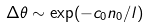<formula> <loc_0><loc_0><loc_500><loc_500>\Delta \theta \sim \exp ( - c _ { 0 } n _ { 0 } / l )</formula> 